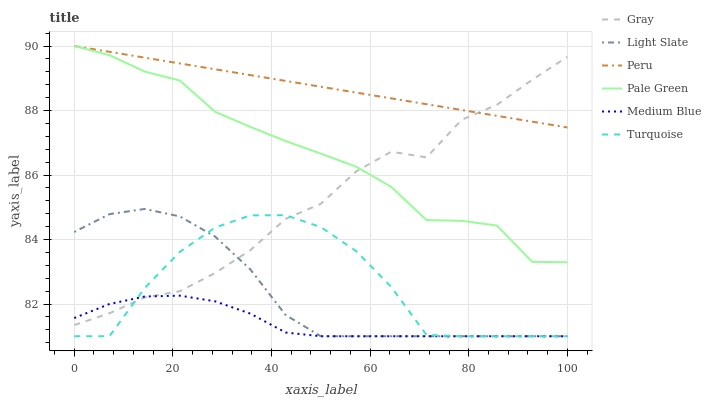Does Medium Blue have the minimum area under the curve?
Answer yes or no. Yes. Does Peru have the maximum area under the curve?
Answer yes or no. Yes. Does Turquoise have the minimum area under the curve?
Answer yes or no. No. Does Turquoise have the maximum area under the curve?
Answer yes or no. No. Is Peru the smoothest?
Answer yes or no. Yes. Is Turquoise the roughest?
Answer yes or no. Yes. Is Light Slate the smoothest?
Answer yes or no. No. Is Light Slate the roughest?
Answer yes or no. No. Does Turquoise have the lowest value?
Answer yes or no. Yes. Does Pale Green have the lowest value?
Answer yes or no. No. Does Peru have the highest value?
Answer yes or no. Yes. Does Turquoise have the highest value?
Answer yes or no. No. Is Light Slate less than Pale Green?
Answer yes or no. Yes. Is Peru greater than Turquoise?
Answer yes or no. Yes. Does Medium Blue intersect Turquoise?
Answer yes or no. Yes. Is Medium Blue less than Turquoise?
Answer yes or no. No. Is Medium Blue greater than Turquoise?
Answer yes or no. No. Does Light Slate intersect Pale Green?
Answer yes or no. No. 